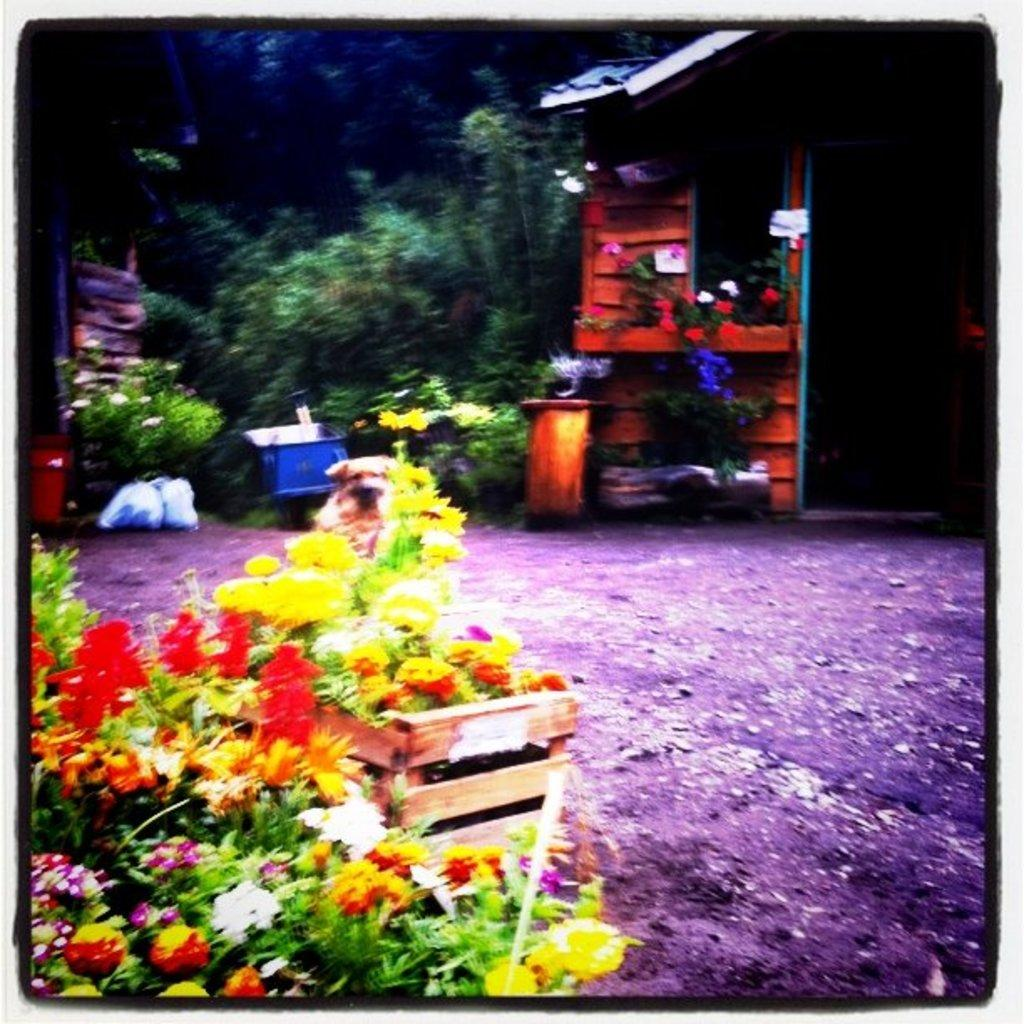What type of house is in the image? There is a wooden house in the image. What can be seen in front of the wooden house? There are flower pots and plants in front of the wooden house. What is on the surface in front of the wooden house? There are objects on the surface in front of the wooden house. What is visible in the background of the image? There are trees in the background of the image. What type of question is being asked in the image? There is no question being asked in the image; it is a static representation of a wooden house and its surroundings. 